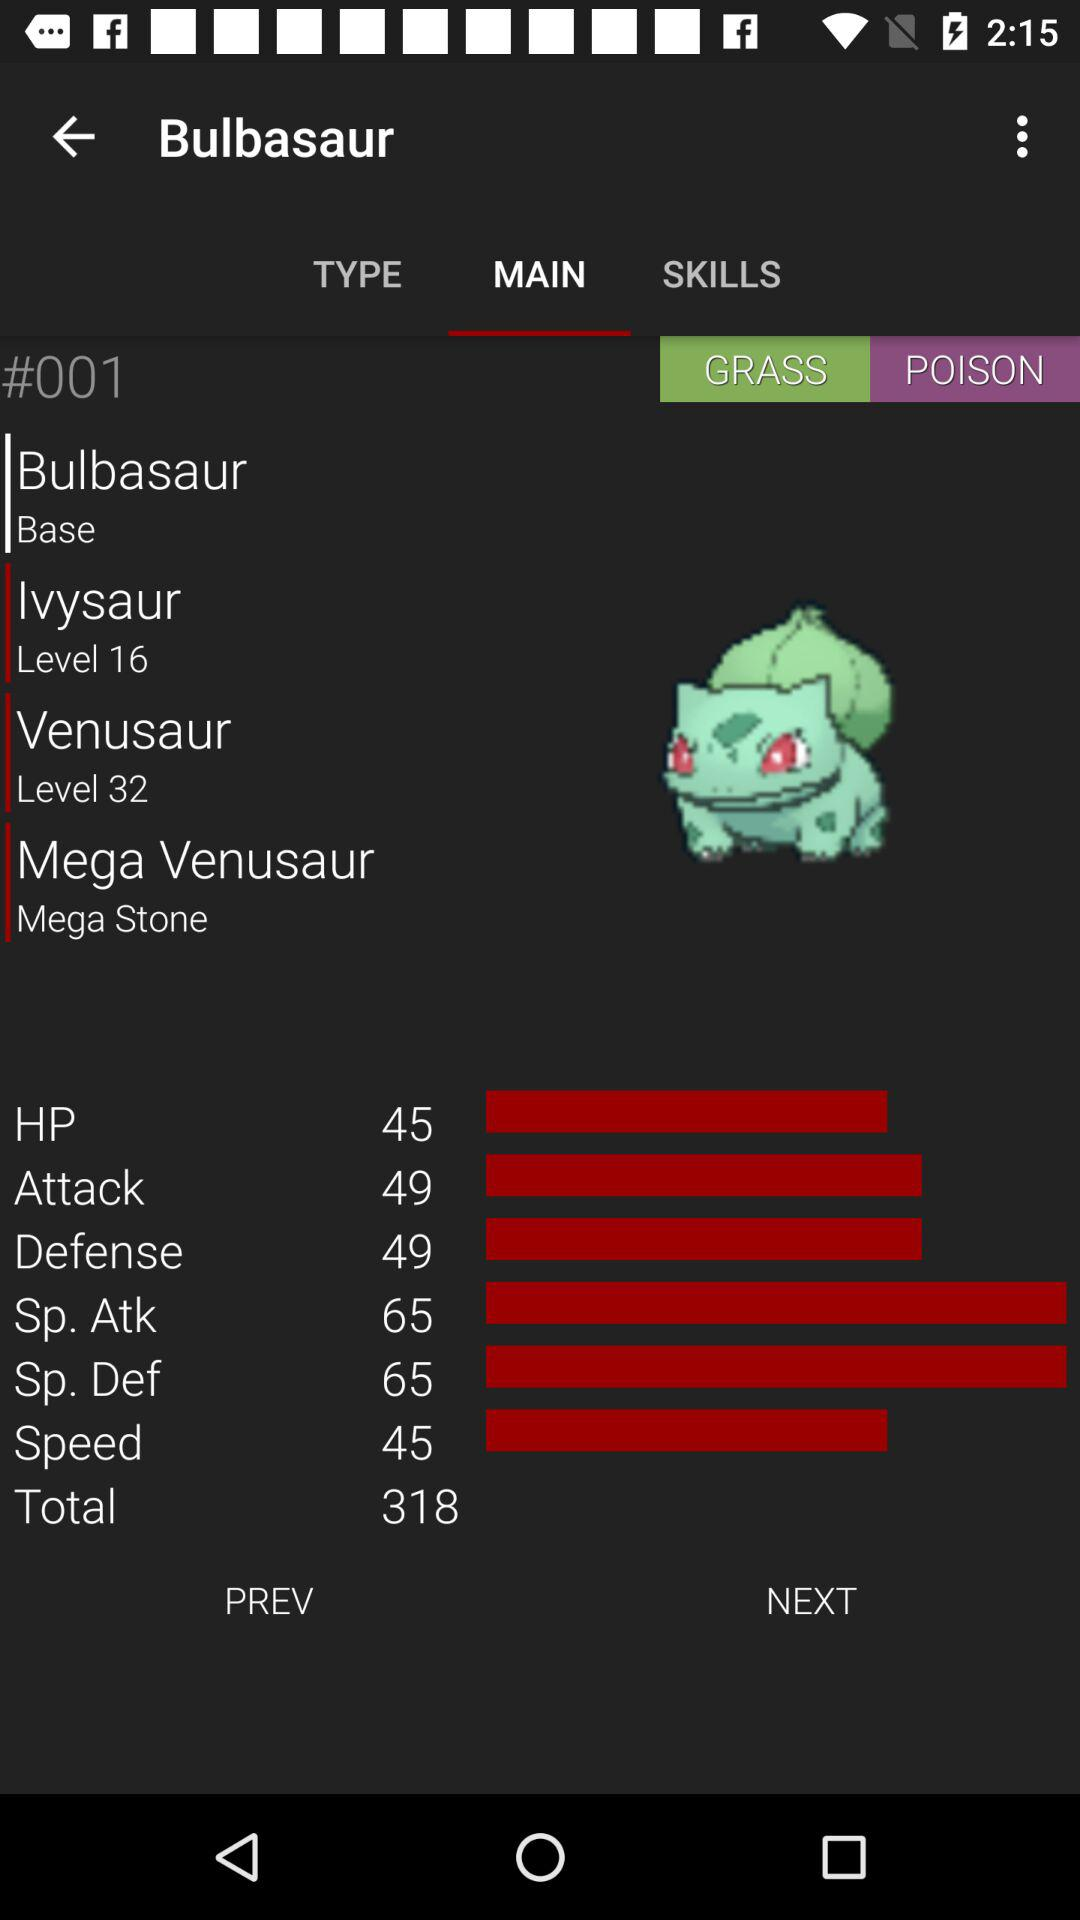What is the level of Venusaur? The level of Venusaur is 32. 